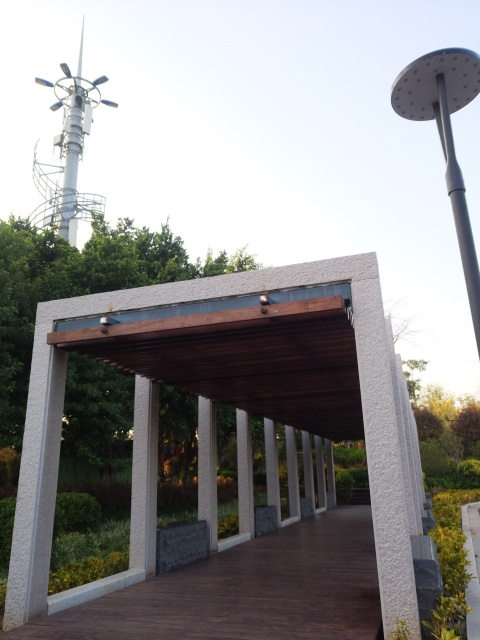Is this a place that people might come to relax? Yes, this appears to be a tranquil spot that people might choose for relaxation. The well-maintained vegetation and the presence of a pathway suggest it's a part of a park or garden. The shelter provided by the structure offers a reprieve from the sun, making it an ideal place for visitors to enjoy a peaceful moment outdoors. 